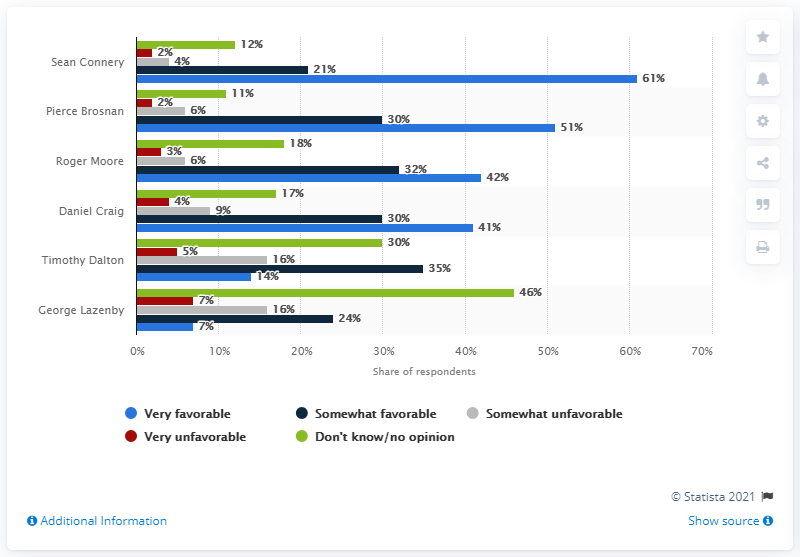Who was the most favorable James Bond actor?
 Sean Connery 